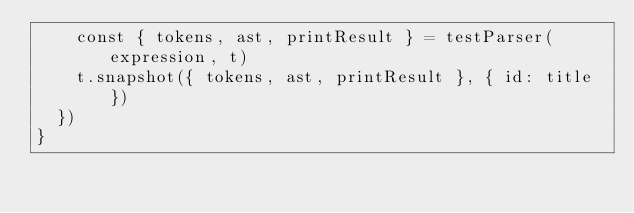Convert code to text. <code><loc_0><loc_0><loc_500><loc_500><_TypeScript_>    const { tokens, ast, printResult } = testParser(expression, t)
    t.snapshot({ tokens, ast, printResult }, { id: title })
  })
}
</code> 